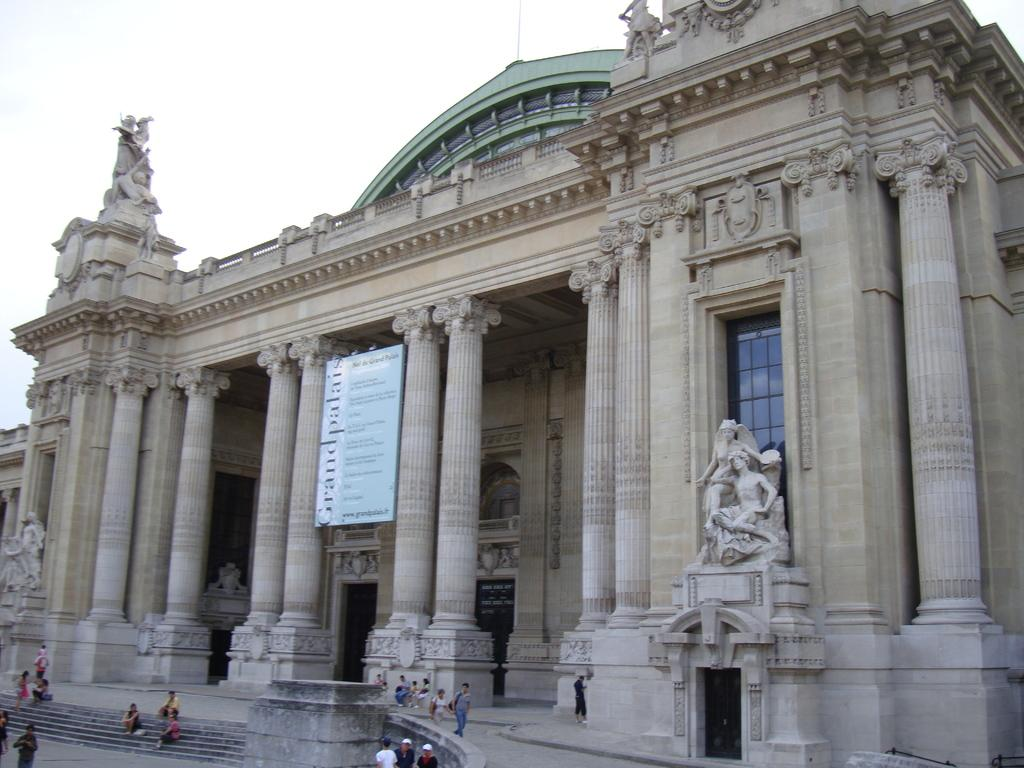Who or what is present in the image? There are people in the image. What can be seen in the distance behind the people? There is a building in the background of the image. What part of the natural environment is visible in the image? The sky is visible in the background of the image. What type of worm can be seen crawling on the building in the image? There are no worms present in the image, and the building is not mentioned as having any worms on it. 